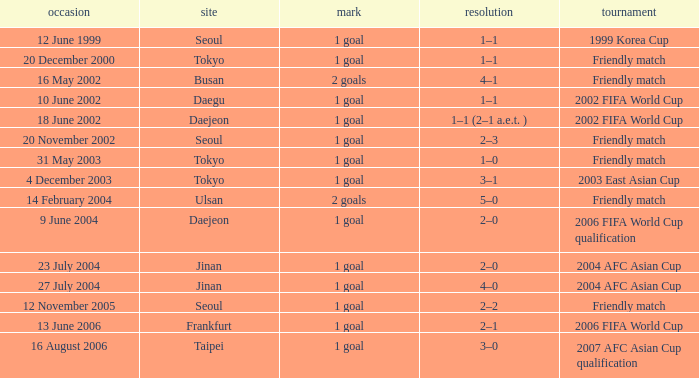What is the competition that occured on 27 July 2004? 2004 AFC Asian Cup. 